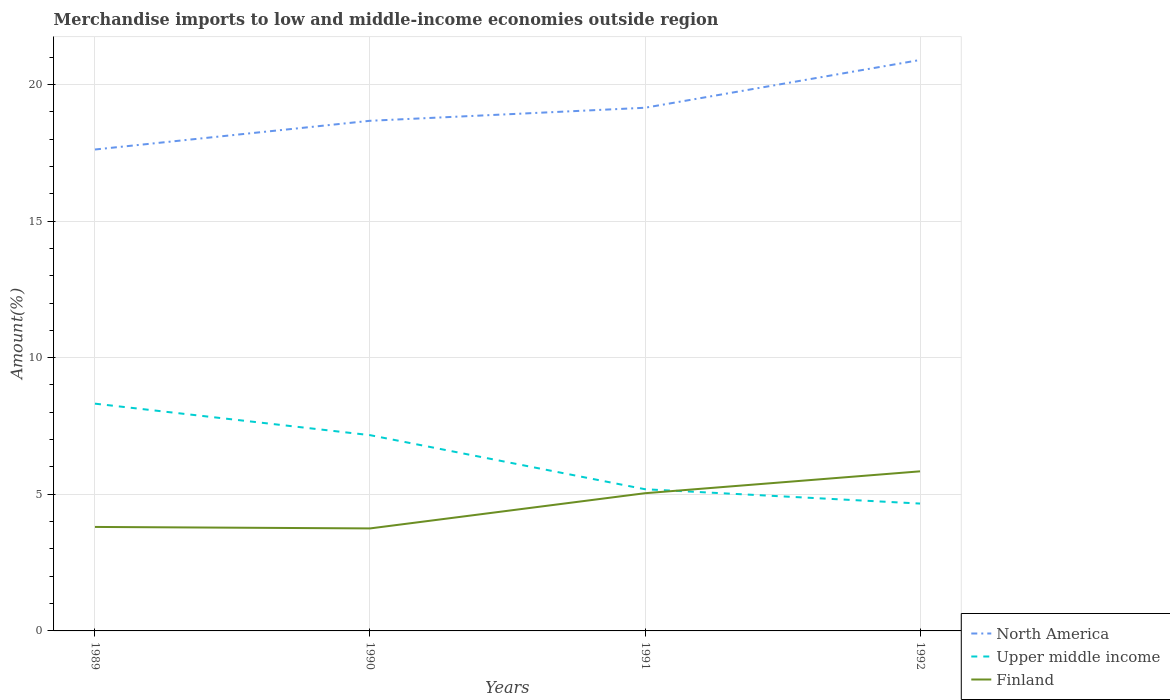How many different coloured lines are there?
Provide a succinct answer. 3. Is the number of lines equal to the number of legend labels?
Keep it short and to the point. Yes. Across all years, what is the maximum percentage of amount earned from merchandise imports in North America?
Offer a terse response. 17.62. What is the total percentage of amount earned from merchandise imports in Finland in the graph?
Ensure brevity in your answer.  -2.09. What is the difference between the highest and the second highest percentage of amount earned from merchandise imports in North America?
Make the answer very short. 3.28. Is the percentage of amount earned from merchandise imports in Upper middle income strictly greater than the percentage of amount earned from merchandise imports in Finland over the years?
Offer a very short reply. No. How many lines are there?
Your response must be concise. 3. What is the difference between two consecutive major ticks on the Y-axis?
Keep it short and to the point. 5. Does the graph contain grids?
Ensure brevity in your answer.  Yes. How are the legend labels stacked?
Your answer should be very brief. Vertical. What is the title of the graph?
Make the answer very short. Merchandise imports to low and middle-income economies outside region. What is the label or title of the X-axis?
Your response must be concise. Years. What is the label or title of the Y-axis?
Offer a very short reply. Amount(%). What is the Amount(%) of North America in 1989?
Your response must be concise. 17.62. What is the Amount(%) in Upper middle income in 1989?
Offer a very short reply. 8.32. What is the Amount(%) of Finland in 1989?
Offer a terse response. 3.81. What is the Amount(%) in North America in 1990?
Your answer should be compact. 18.67. What is the Amount(%) in Upper middle income in 1990?
Your answer should be compact. 7.16. What is the Amount(%) of Finland in 1990?
Your response must be concise. 3.75. What is the Amount(%) of North America in 1991?
Your response must be concise. 19.15. What is the Amount(%) in Upper middle income in 1991?
Give a very brief answer. 5.19. What is the Amount(%) of Finland in 1991?
Keep it short and to the point. 5.04. What is the Amount(%) in North America in 1992?
Ensure brevity in your answer.  20.89. What is the Amount(%) of Upper middle income in 1992?
Your response must be concise. 4.66. What is the Amount(%) of Finland in 1992?
Ensure brevity in your answer.  5.84. Across all years, what is the maximum Amount(%) of North America?
Your answer should be very brief. 20.89. Across all years, what is the maximum Amount(%) in Upper middle income?
Your answer should be very brief. 8.32. Across all years, what is the maximum Amount(%) of Finland?
Your answer should be compact. 5.84. Across all years, what is the minimum Amount(%) of North America?
Keep it short and to the point. 17.62. Across all years, what is the minimum Amount(%) of Upper middle income?
Your answer should be compact. 4.66. Across all years, what is the minimum Amount(%) of Finland?
Provide a short and direct response. 3.75. What is the total Amount(%) of North America in the graph?
Provide a short and direct response. 76.33. What is the total Amount(%) of Upper middle income in the graph?
Make the answer very short. 25.33. What is the total Amount(%) of Finland in the graph?
Keep it short and to the point. 18.44. What is the difference between the Amount(%) in North America in 1989 and that in 1990?
Make the answer very short. -1.05. What is the difference between the Amount(%) of Upper middle income in 1989 and that in 1990?
Your answer should be very brief. 1.15. What is the difference between the Amount(%) of Finland in 1989 and that in 1990?
Your response must be concise. 0.05. What is the difference between the Amount(%) in North America in 1989 and that in 1991?
Keep it short and to the point. -1.53. What is the difference between the Amount(%) in Upper middle income in 1989 and that in 1991?
Offer a terse response. 3.13. What is the difference between the Amount(%) in Finland in 1989 and that in 1991?
Give a very brief answer. -1.23. What is the difference between the Amount(%) of North America in 1989 and that in 1992?
Your answer should be very brief. -3.28. What is the difference between the Amount(%) in Upper middle income in 1989 and that in 1992?
Provide a succinct answer. 3.66. What is the difference between the Amount(%) of Finland in 1989 and that in 1992?
Provide a short and direct response. -2.03. What is the difference between the Amount(%) of North America in 1990 and that in 1991?
Your answer should be very brief. -0.48. What is the difference between the Amount(%) in Upper middle income in 1990 and that in 1991?
Your answer should be very brief. 1.98. What is the difference between the Amount(%) of Finland in 1990 and that in 1991?
Your answer should be very brief. -1.29. What is the difference between the Amount(%) in North America in 1990 and that in 1992?
Offer a very short reply. -2.22. What is the difference between the Amount(%) in Upper middle income in 1990 and that in 1992?
Provide a succinct answer. 2.5. What is the difference between the Amount(%) in Finland in 1990 and that in 1992?
Keep it short and to the point. -2.09. What is the difference between the Amount(%) of North America in 1991 and that in 1992?
Give a very brief answer. -1.75. What is the difference between the Amount(%) in Upper middle income in 1991 and that in 1992?
Your response must be concise. 0.52. What is the difference between the Amount(%) in Finland in 1991 and that in 1992?
Provide a succinct answer. -0.8. What is the difference between the Amount(%) in North America in 1989 and the Amount(%) in Upper middle income in 1990?
Keep it short and to the point. 10.45. What is the difference between the Amount(%) of North America in 1989 and the Amount(%) of Finland in 1990?
Your answer should be very brief. 13.87. What is the difference between the Amount(%) of Upper middle income in 1989 and the Amount(%) of Finland in 1990?
Provide a short and direct response. 4.57. What is the difference between the Amount(%) of North America in 1989 and the Amount(%) of Upper middle income in 1991?
Your answer should be very brief. 12.43. What is the difference between the Amount(%) in North America in 1989 and the Amount(%) in Finland in 1991?
Ensure brevity in your answer.  12.58. What is the difference between the Amount(%) in Upper middle income in 1989 and the Amount(%) in Finland in 1991?
Offer a terse response. 3.28. What is the difference between the Amount(%) of North America in 1989 and the Amount(%) of Upper middle income in 1992?
Keep it short and to the point. 12.96. What is the difference between the Amount(%) of North America in 1989 and the Amount(%) of Finland in 1992?
Your response must be concise. 11.78. What is the difference between the Amount(%) of Upper middle income in 1989 and the Amount(%) of Finland in 1992?
Give a very brief answer. 2.48. What is the difference between the Amount(%) of North America in 1990 and the Amount(%) of Upper middle income in 1991?
Your response must be concise. 13.48. What is the difference between the Amount(%) of North America in 1990 and the Amount(%) of Finland in 1991?
Offer a very short reply. 13.63. What is the difference between the Amount(%) of Upper middle income in 1990 and the Amount(%) of Finland in 1991?
Keep it short and to the point. 2.13. What is the difference between the Amount(%) in North America in 1990 and the Amount(%) in Upper middle income in 1992?
Keep it short and to the point. 14.01. What is the difference between the Amount(%) of North America in 1990 and the Amount(%) of Finland in 1992?
Give a very brief answer. 12.83. What is the difference between the Amount(%) in Upper middle income in 1990 and the Amount(%) in Finland in 1992?
Your response must be concise. 1.32. What is the difference between the Amount(%) of North America in 1991 and the Amount(%) of Upper middle income in 1992?
Offer a terse response. 14.49. What is the difference between the Amount(%) of North America in 1991 and the Amount(%) of Finland in 1992?
Your answer should be very brief. 13.31. What is the difference between the Amount(%) in Upper middle income in 1991 and the Amount(%) in Finland in 1992?
Make the answer very short. -0.65. What is the average Amount(%) of North America per year?
Keep it short and to the point. 19.08. What is the average Amount(%) of Upper middle income per year?
Keep it short and to the point. 6.33. What is the average Amount(%) in Finland per year?
Ensure brevity in your answer.  4.61. In the year 1989, what is the difference between the Amount(%) in North America and Amount(%) in Upper middle income?
Keep it short and to the point. 9.3. In the year 1989, what is the difference between the Amount(%) of North America and Amount(%) of Finland?
Ensure brevity in your answer.  13.81. In the year 1989, what is the difference between the Amount(%) in Upper middle income and Amount(%) in Finland?
Provide a succinct answer. 4.51. In the year 1990, what is the difference between the Amount(%) of North America and Amount(%) of Upper middle income?
Offer a terse response. 11.5. In the year 1990, what is the difference between the Amount(%) of North America and Amount(%) of Finland?
Make the answer very short. 14.92. In the year 1990, what is the difference between the Amount(%) in Upper middle income and Amount(%) in Finland?
Provide a succinct answer. 3.41. In the year 1991, what is the difference between the Amount(%) of North America and Amount(%) of Upper middle income?
Give a very brief answer. 13.96. In the year 1991, what is the difference between the Amount(%) in North America and Amount(%) in Finland?
Your answer should be very brief. 14.11. In the year 1991, what is the difference between the Amount(%) in Upper middle income and Amount(%) in Finland?
Ensure brevity in your answer.  0.15. In the year 1992, what is the difference between the Amount(%) in North America and Amount(%) in Upper middle income?
Offer a very short reply. 16.23. In the year 1992, what is the difference between the Amount(%) in North America and Amount(%) in Finland?
Give a very brief answer. 15.05. In the year 1992, what is the difference between the Amount(%) of Upper middle income and Amount(%) of Finland?
Your response must be concise. -1.18. What is the ratio of the Amount(%) of North America in 1989 to that in 1990?
Offer a terse response. 0.94. What is the ratio of the Amount(%) of Upper middle income in 1989 to that in 1990?
Provide a short and direct response. 1.16. What is the ratio of the Amount(%) of Finland in 1989 to that in 1990?
Offer a terse response. 1.01. What is the ratio of the Amount(%) of North America in 1989 to that in 1991?
Provide a succinct answer. 0.92. What is the ratio of the Amount(%) of Upper middle income in 1989 to that in 1991?
Your response must be concise. 1.6. What is the ratio of the Amount(%) in Finland in 1989 to that in 1991?
Your answer should be very brief. 0.76. What is the ratio of the Amount(%) in North America in 1989 to that in 1992?
Offer a very short reply. 0.84. What is the ratio of the Amount(%) of Upper middle income in 1989 to that in 1992?
Your response must be concise. 1.78. What is the ratio of the Amount(%) of Finland in 1989 to that in 1992?
Keep it short and to the point. 0.65. What is the ratio of the Amount(%) in North America in 1990 to that in 1991?
Give a very brief answer. 0.98. What is the ratio of the Amount(%) in Upper middle income in 1990 to that in 1991?
Keep it short and to the point. 1.38. What is the ratio of the Amount(%) in Finland in 1990 to that in 1991?
Your response must be concise. 0.74. What is the ratio of the Amount(%) in North America in 1990 to that in 1992?
Your answer should be compact. 0.89. What is the ratio of the Amount(%) in Upper middle income in 1990 to that in 1992?
Your answer should be compact. 1.54. What is the ratio of the Amount(%) in Finland in 1990 to that in 1992?
Ensure brevity in your answer.  0.64. What is the ratio of the Amount(%) in North America in 1991 to that in 1992?
Make the answer very short. 0.92. What is the ratio of the Amount(%) in Upper middle income in 1991 to that in 1992?
Give a very brief answer. 1.11. What is the ratio of the Amount(%) of Finland in 1991 to that in 1992?
Make the answer very short. 0.86. What is the difference between the highest and the second highest Amount(%) in North America?
Your answer should be very brief. 1.75. What is the difference between the highest and the second highest Amount(%) of Upper middle income?
Provide a succinct answer. 1.15. What is the difference between the highest and the second highest Amount(%) in Finland?
Give a very brief answer. 0.8. What is the difference between the highest and the lowest Amount(%) of North America?
Provide a short and direct response. 3.28. What is the difference between the highest and the lowest Amount(%) of Upper middle income?
Provide a succinct answer. 3.66. What is the difference between the highest and the lowest Amount(%) of Finland?
Provide a short and direct response. 2.09. 